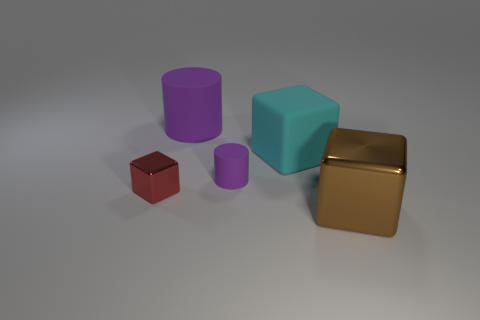Are there any large metallic things that have the same color as the large rubber cylinder?
Offer a very short reply. No. Are there any other cyan cubes made of the same material as the cyan cube?
Offer a very short reply. No. There is a object that is to the left of the tiny matte object and behind the small cube; what is its shape?
Make the answer very short. Cylinder. How many tiny things are either blocks or objects?
Make the answer very short. 2. What is the red thing made of?
Offer a very short reply. Metal. How many other objects are the same shape as the tiny purple object?
Keep it short and to the point. 1. What size is the red metallic cube?
Offer a terse response. Small. How big is the cube that is left of the large shiny object and in front of the large cyan object?
Your response must be concise. Small. There is a metal object that is left of the large shiny cube; what is its shape?
Offer a terse response. Cube. Is the large purple cylinder made of the same material as the thing in front of the tiny red shiny cube?
Keep it short and to the point. No. 